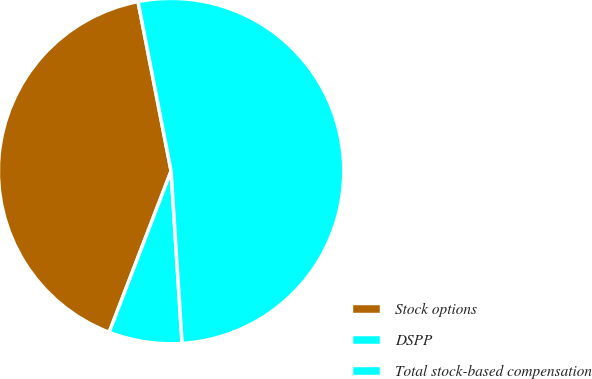Convert chart. <chart><loc_0><loc_0><loc_500><loc_500><pie_chart><fcel>Stock options<fcel>DSPP<fcel>Total stock-based compensation<nl><fcel>41.1%<fcel>6.85%<fcel>52.05%<nl></chart> 